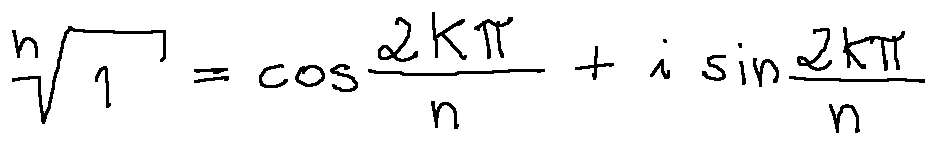Convert formula to latex. <formula><loc_0><loc_0><loc_500><loc_500>\sqrt { [ } n ] { 1 } = \cos \frac { 2 k \pi } { n } + i \sin \frac { 2 k \pi } { n }</formula> 